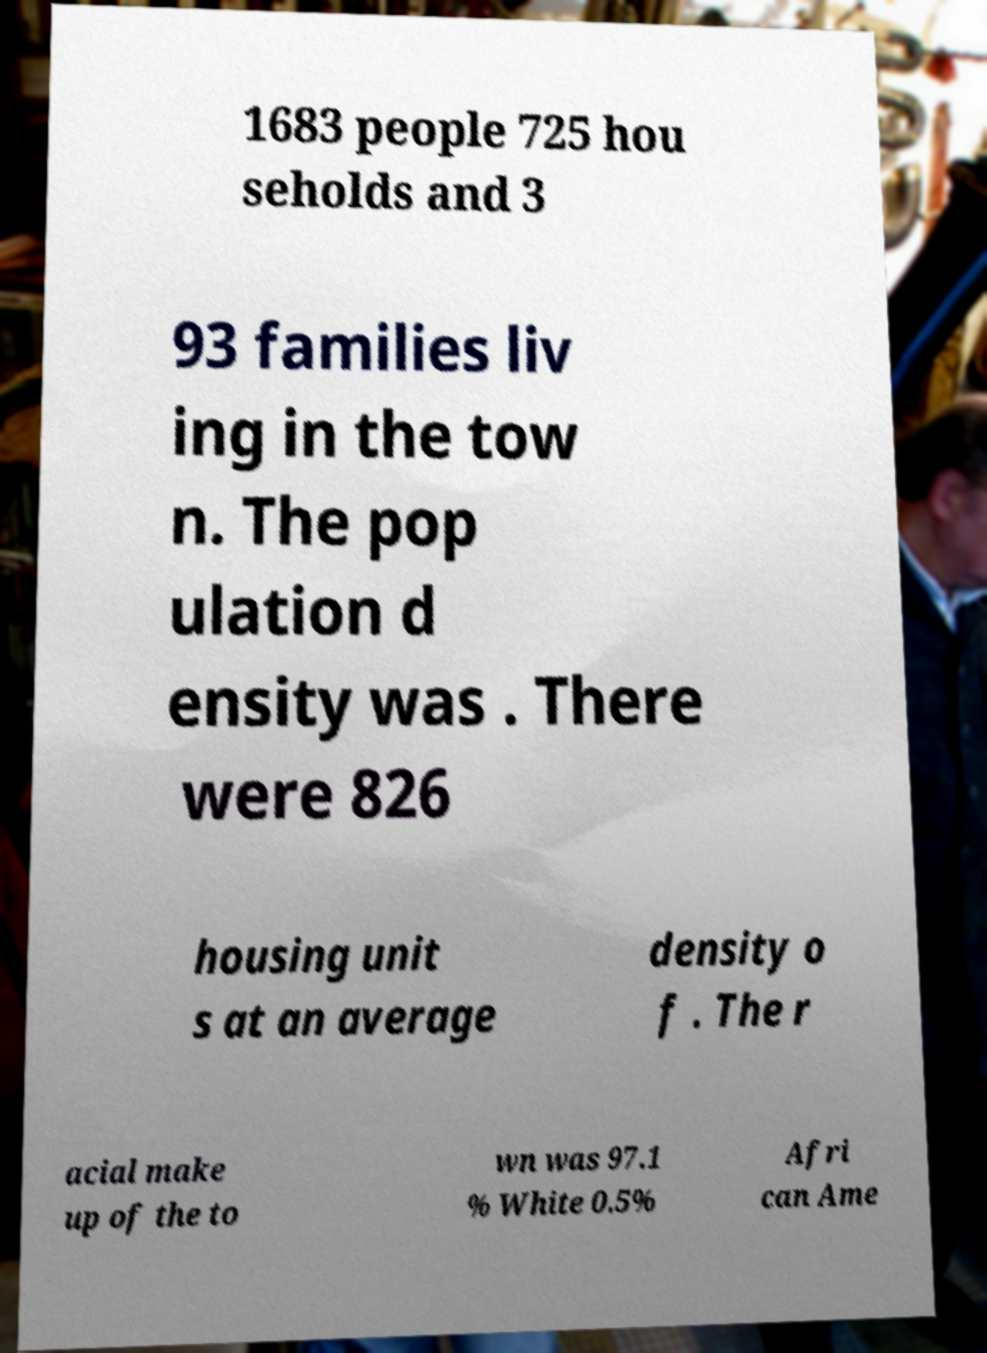Please read and relay the text visible in this image. What does it say? 1683 people 725 hou seholds and 3 93 families liv ing in the tow n. The pop ulation d ensity was . There were 826 housing unit s at an average density o f . The r acial make up of the to wn was 97.1 % White 0.5% Afri can Ame 